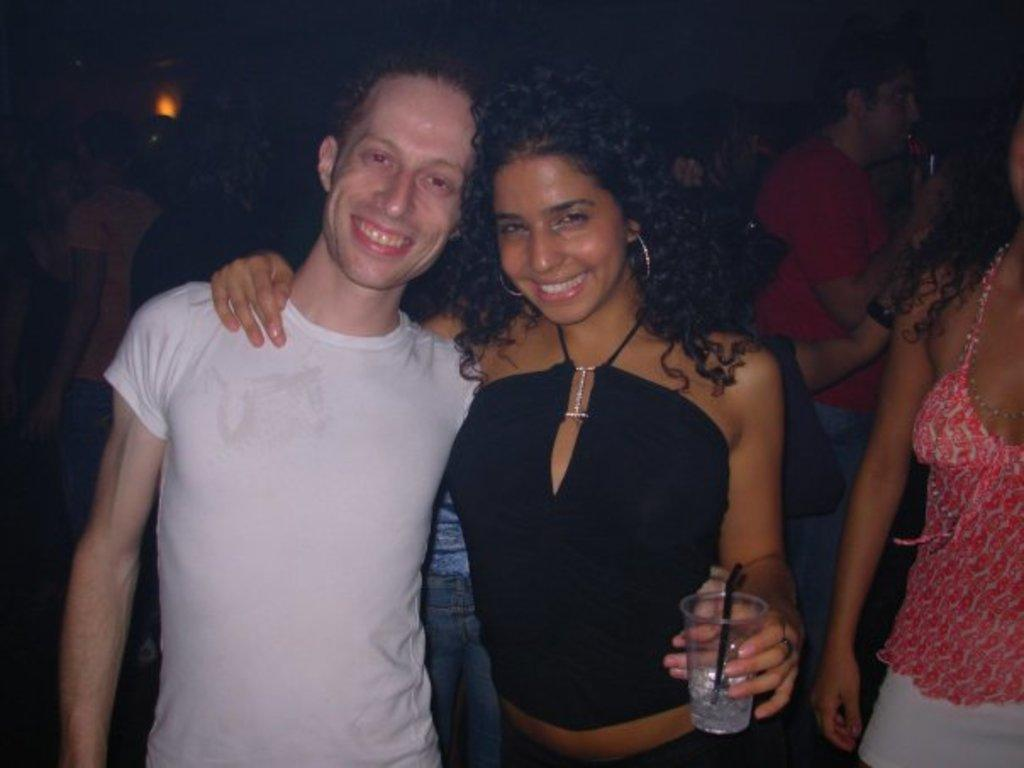How many people are present in the image? There are two people, a man and a woman, present in the image. What are the man and woman doing in the image? Both the man and woman are standing and smiling. What is the woman holding in her hand? The woman is holding a glass in her hand. What can be seen in the background of the image? There are people and a light in the background of the image. What type of shoes is the visitor wearing in the image? There is no visitor present in the image, so it is not possible to determine what type of shoes they might be wearing. 